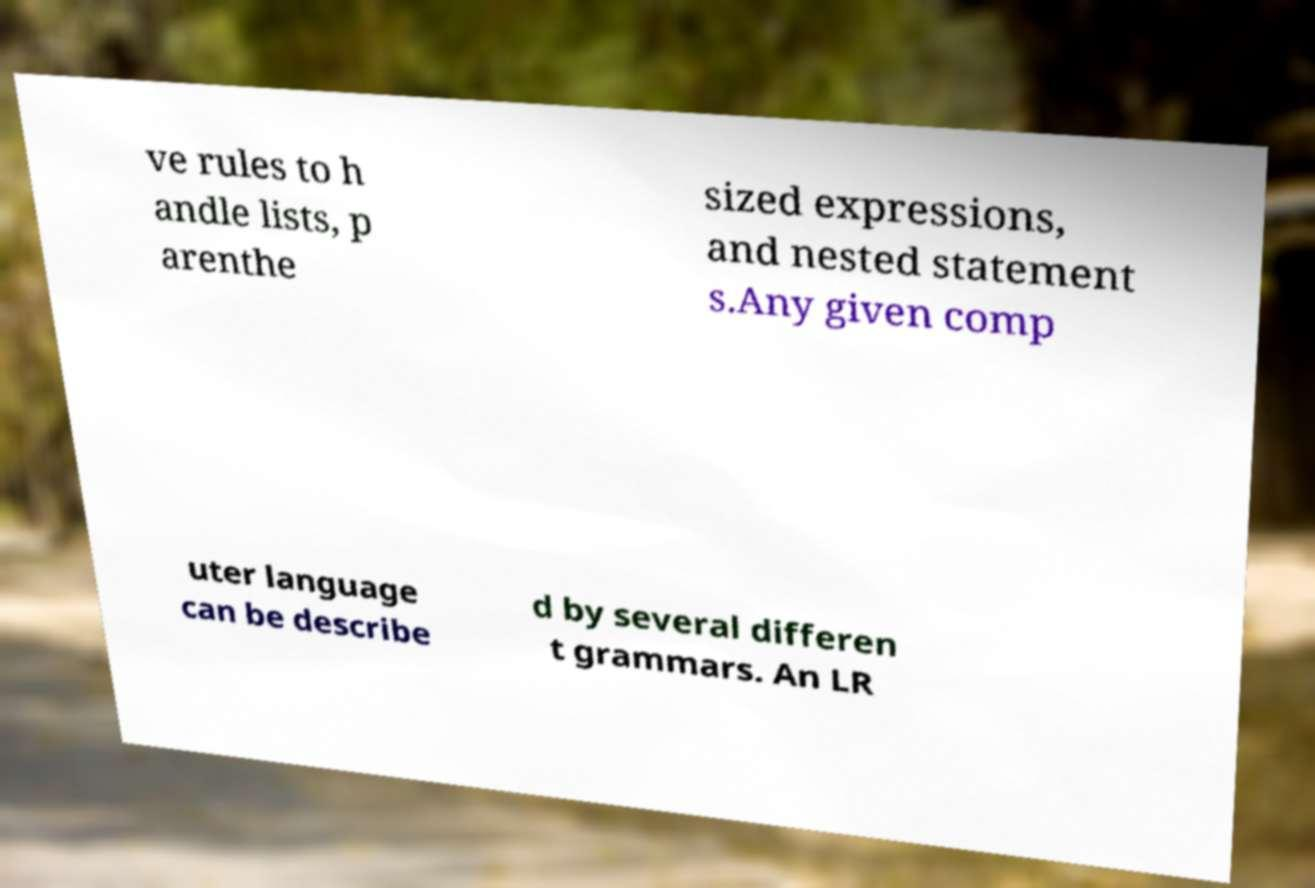There's text embedded in this image that I need extracted. Can you transcribe it verbatim? ve rules to h andle lists, p arenthe sized expressions, and nested statement s.Any given comp uter language can be describe d by several differen t grammars. An LR 